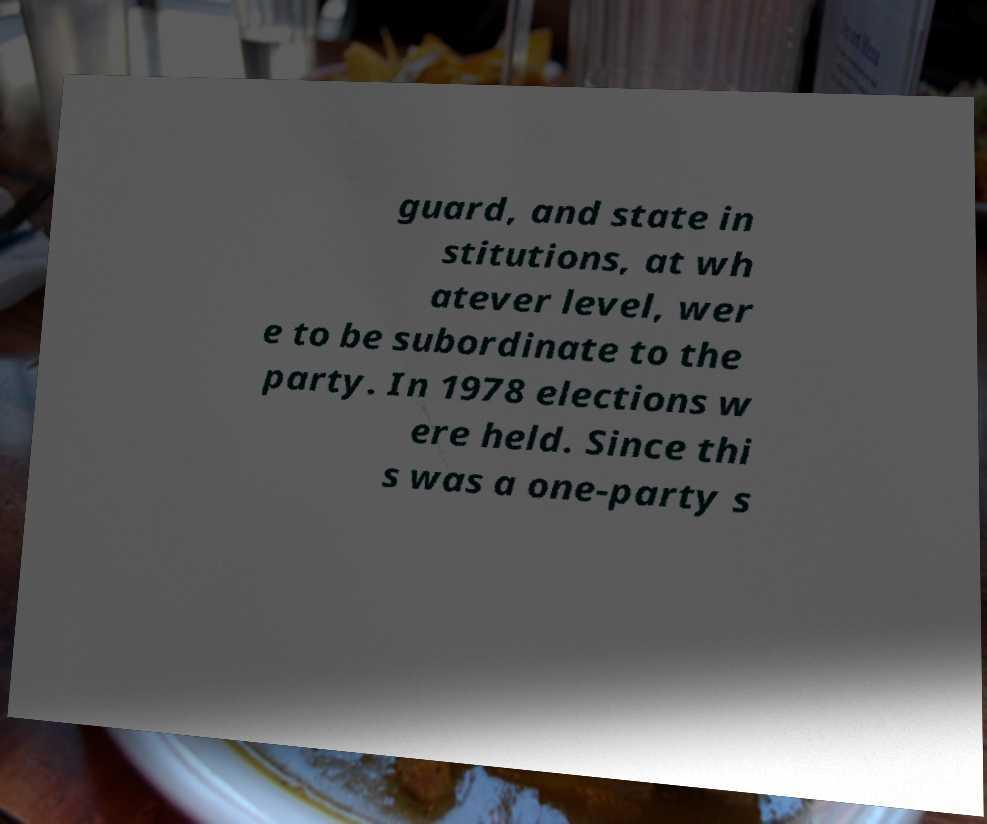Can you accurately transcribe the text from the provided image for me? guard, and state in stitutions, at wh atever level, wer e to be subordinate to the party. In 1978 elections w ere held. Since thi s was a one-party s 